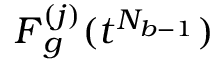<formula> <loc_0><loc_0><loc_500><loc_500>F _ { g } ^ { ( j ) } ( t ^ { N _ { b - 1 } } )</formula> 